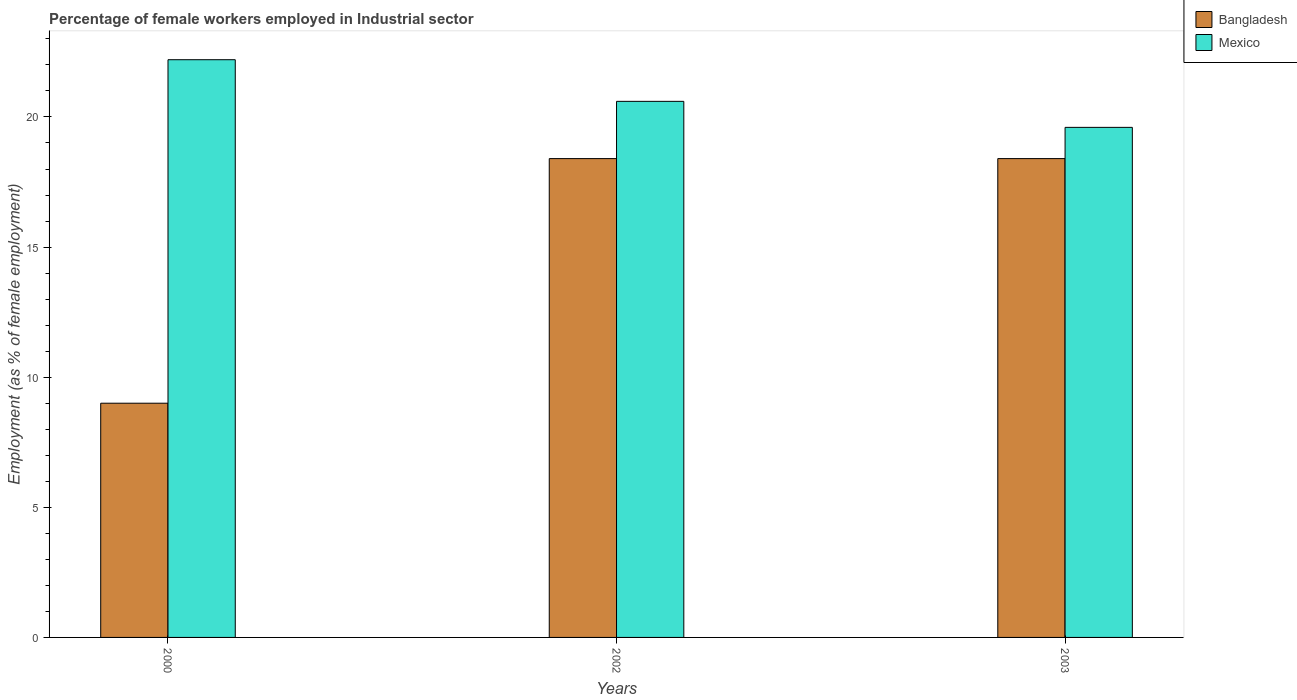How many groups of bars are there?
Offer a terse response. 3. Are the number of bars per tick equal to the number of legend labels?
Provide a short and direct response. Yes. Are the number of bars on each tick of the X-axis equal?
Offer a terse response. Yes. How many bars are there on the 2nd tick from the right?
Your answer should be compact. 2. What is the label of the 1st group of bars from the left?
Offer a terse response. 2000. What is the percentage of females employed in Industrial sector in Bangladesh in 2000?
Provide a short and direct response. 9. Across all years, what is the maximum percentage of females employed in Industrial sector in Bangladesh?
Your answer should be very brief. 18.4. Across all years, what is the minimum percentage of females employed in Industrial sector in Mexico?
Your response must be concise. 19.6. In which year was the percentage of females employed in Industrial sector in Bangladesh maximum?
Ensure brevity in your answer.  2002. What is the total percentage of females employed in Industrial sector in Mexico in the graph?
Provide a succinct answer. 62.4. What is the difference between the percentage of females employed in Industrial sector in Mexico in 2000 and that in 2002?
Ensure brevity in your answer.  1.6. What is the difference between the percentage of females employed in Industrial sector in Bangladesh in 2000 and the percentage of females employed in Industrial sector in Mexico in 2003?
Keep it short and to the point. -10.6. What is the average percentage of females employed in Industrial sector in Mexico per year?
Provide a succinct answer. 20.8. In the year 2003, what is the difference between the percentage of females employed in Industrial sector in Mexico and percentage of females employed in Industrial sector in Bangladesh?
Your response must be concise. 1.2. What is the ratio of the percentage of females employed in Industrial sector in Bangladesh in 2000 to that in 2002?
Provide a succinct answer. 0.49. What is the difference between the highest and the second highest percentage of females employed in Industrial sector in Mexico?
Keep it short and to the point. 1.6. What is the difference between the highest and the lowest percentage of females employed in Industrial sector in Mexico?
Make the answer very short. 2.6. In how many years, is the percentage of females employed in Industrial sector in Bangladesh greater than the average percentage of females employed in Industrial sector in Bangladesh taken over all years?
Keep it short and to the point. 2. What does the 1st bar from the left in 2000 represents?
Offer a terse response. Bangladesh. What does the 1st bar from the right in 2000 represents?
Give a very brief answer. Mexico. How many bars are there?
Offer a terse response. 6. Does the graph contain grids?
Your answer should be very brief. No. How many legend labels are there?
Your answer should be very brief. 2. How are the legend labels stacked?
Your answer should be compact. Vertical. What is the title of the graph?
Your answer should be very brief. Percentage of female workers employed in Industrial sector. What is the label or title of the Y-axis?
Provide a succinct answer. Employment (as % of female employment). What is the Employment (as % of female employment) in Mexico in 2000?
Keep it short and to the point. 22.2. What is the Employment (as % of female employment) in Bangladesh in 2002?
Ensure brevity in your answer.  18.4. What is the Employment (as % of female employment) in Mexico in 2002?
Give a very brief answer. 20.6. What is the Employment (as % of female employment) in Bangladesh in 2003?
Keep it short and to the point. 18.4. What is the Employment (as % of female employment) of Mexico in 2003?
Offer a terse response. 19.6. Across all years, what is the maximum Employment (as % of female employment) in Bangladesh?
Your answer should be compact. 18.4. Across all years, what is the maximum Employment (as % of female employment) of Mexico?
Provide a short and direct response. 22.2. Across all years, what is the minimum Employment (as % of female employment) of Mexico?
Give a very brief answer. 19.6. What is the total Employment (as % of female employment) in Bangladesh in the graph?
Your answer should be very brief. 45.8. What is the total Employment (as % of female employment) of Mexico in the graph?
Provide a succinct answer. 62.4. What is the difference between the Employment (as % of female employment) in Mexico in 2000 and that in 2002?
Your answer should be very brief. 1.6. What is the difference between the Employment (as % of female employment) in Mexico in 2000 and that in 2003?
Ensure brevity in your answer.  2.6. What is the difference between the Employment (as % of female employment) of Bangladesh in 2002 and that in 2003?
Give a very brief answer. 0. What is the difference between the Employment (as % of female employment) in Bangladesh in 2000 and the Employment (as % of female employment) in Mexico in 2002?
Keep it short and to the point. -11.6. What is the difference between the Employment (as % of female employment) in Bangladesh in 2002 and the Employment (as % of female employment) in Mexico in 2003?
Make the answer very short. -1.2. What is the average Employment (as % of female employment) in Bangladesh per year?
Ensure brevity in your answer.  15.27. What is the average Employment (as % of female employment) of Mexico per year?
Provide a short and direct response. 20.8. In the year 2000, what is the difference between the Employment (as % of female employment) of Bangladesh and Employment (as % of female employment) of Mexico?
Keep it short and to the point. -13.2. In the year 2002, what is the difference between the Employment (as % of female employment) of Bangladesh and Employment (as % of female employment) of Mexico?
Provide a short and direct response. -2.2. What is the ratio of the Employment (as % of female employment) in Bangladesh in 2000 to that in 2002?
Offer a very short reply. 0.49. What is the ratio of the Employment (as % of female employment) of Mexico in 2000 to that in 2002?
Your response must be concise. 1.08. What is the ratio of the Employment (as % of female employment) of Bangladesh in 2000 to that in 2003?
Give a very brief answer. 0.49. What is the ratio of the Employment (as % of female employment) of Mexico in 2000 to that in 2003?
Provide a short and direct response. 1.13. What is the ratio of the Employment (as % of female employment) in Mexico in 2002 to that in 2003?
Your answer should be compact. 1.05. What is the difference between the highest and the second highest Employment (as % of female employment) of Mexico?
Provide a short and direct response. 1.6. What is the difference between the highest and the lowest Employment (as % of female employment) in Bangladesh?
Provide a succinct answer. 9.4. 